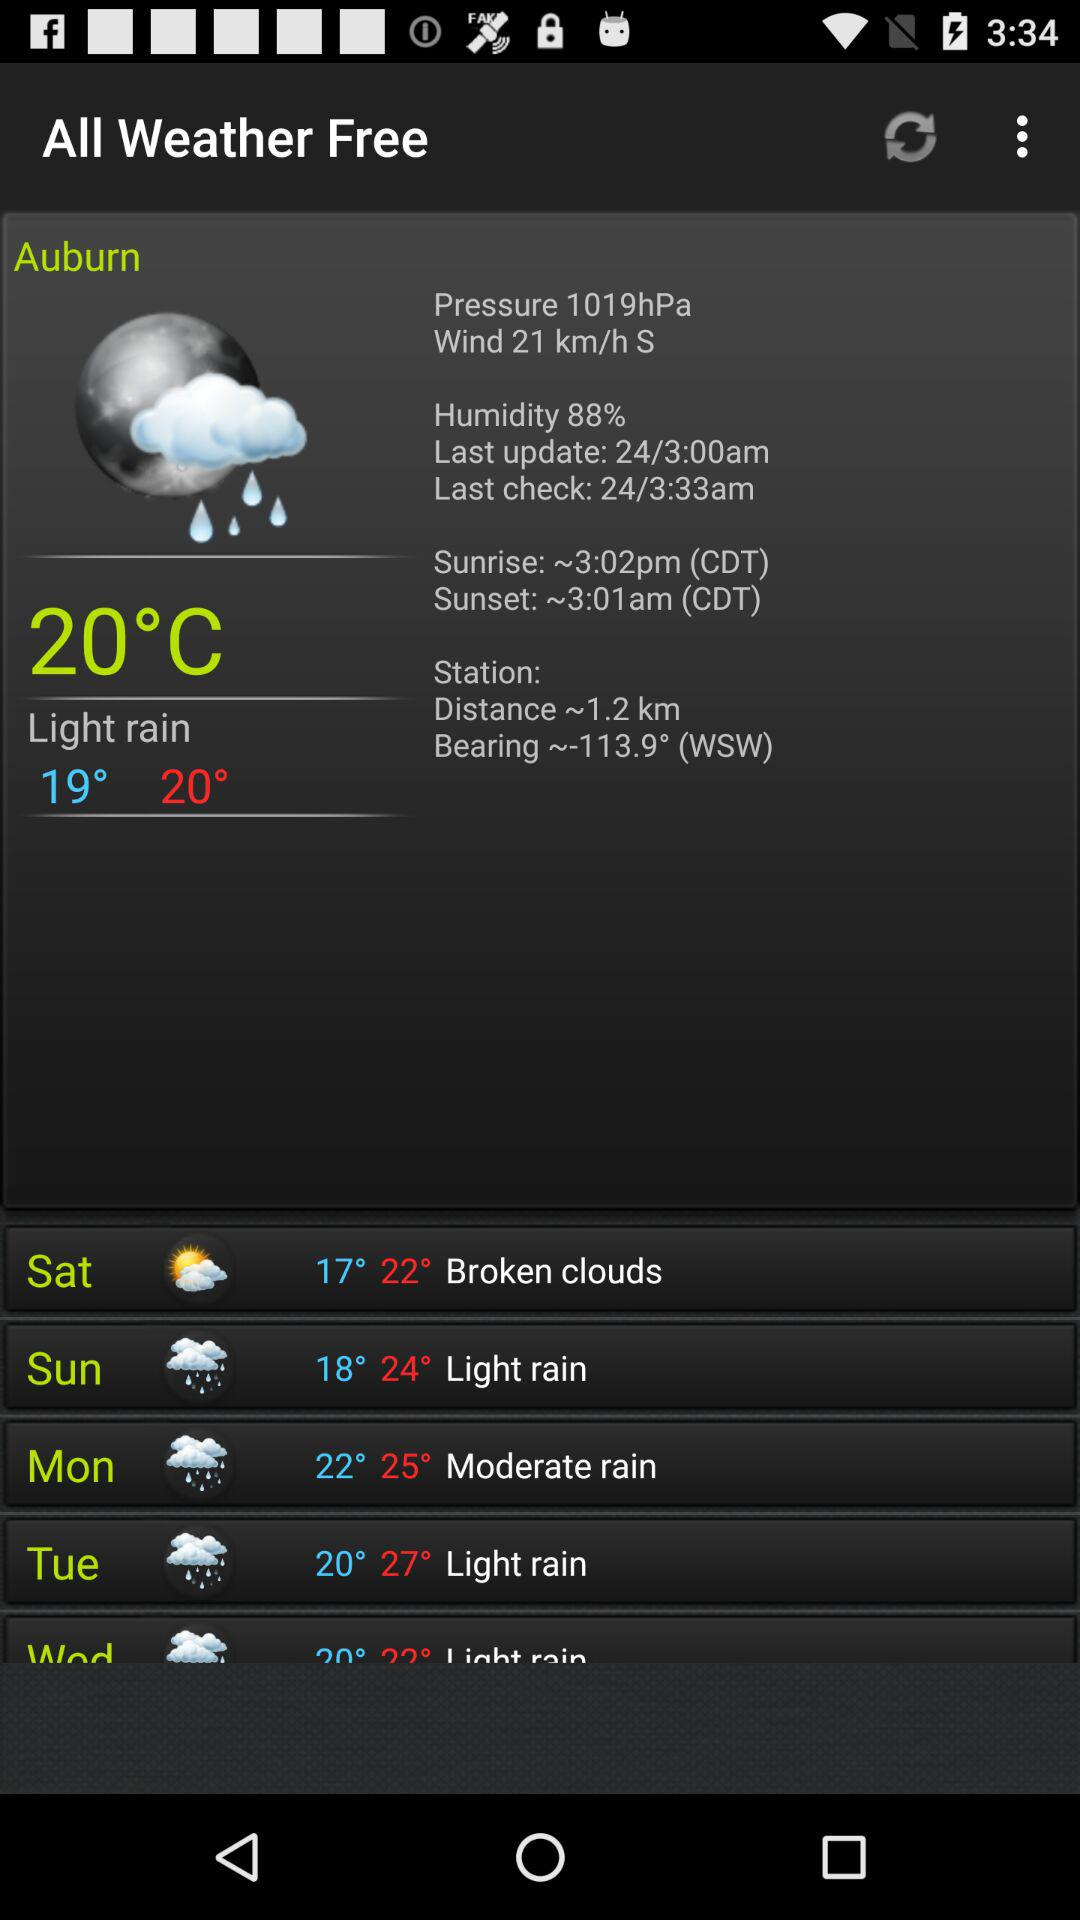What is the lowest recorded temperature on Saturday? The lowest temperature on Saturday is 17°. 